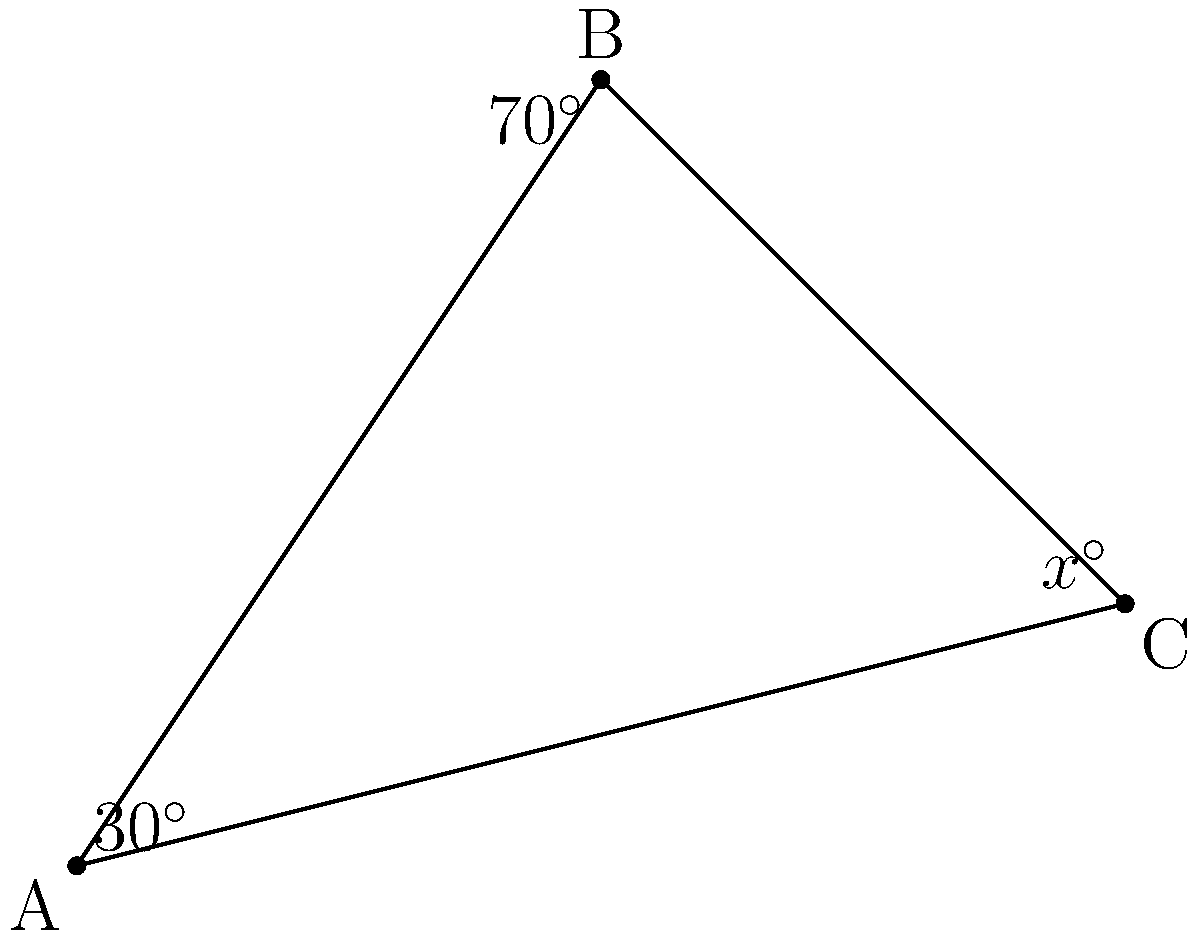In a recent tournament, you noticed three of your rival's darts clustered on the board forming a triangle. The angles formed at two corners of this triangle are 30° and 70°. What is the measure of the angle at the third corner, represented by $x$ in the diagram? To find the measure of the third angle, we can follow these steps:

1. Recall that the sum of angles in a triangle is always 180°.

2. Let's express this mathematically:
   $30^\circ + 70^\circ + x^\circ = 180^\circ$

3. Simplify the known angles:
   $100^\circ + x^\circ = 180^\circ$

4. Subtract 100° from both sides:
   $x^\circ = 180^\circ - 100^\circ$

5. Perform the subtraction:
   $x^\circ = 80^\circ$

Therefore, the measure of the third angle in the triangle is 80°.
Answer: $80^\circ$ 